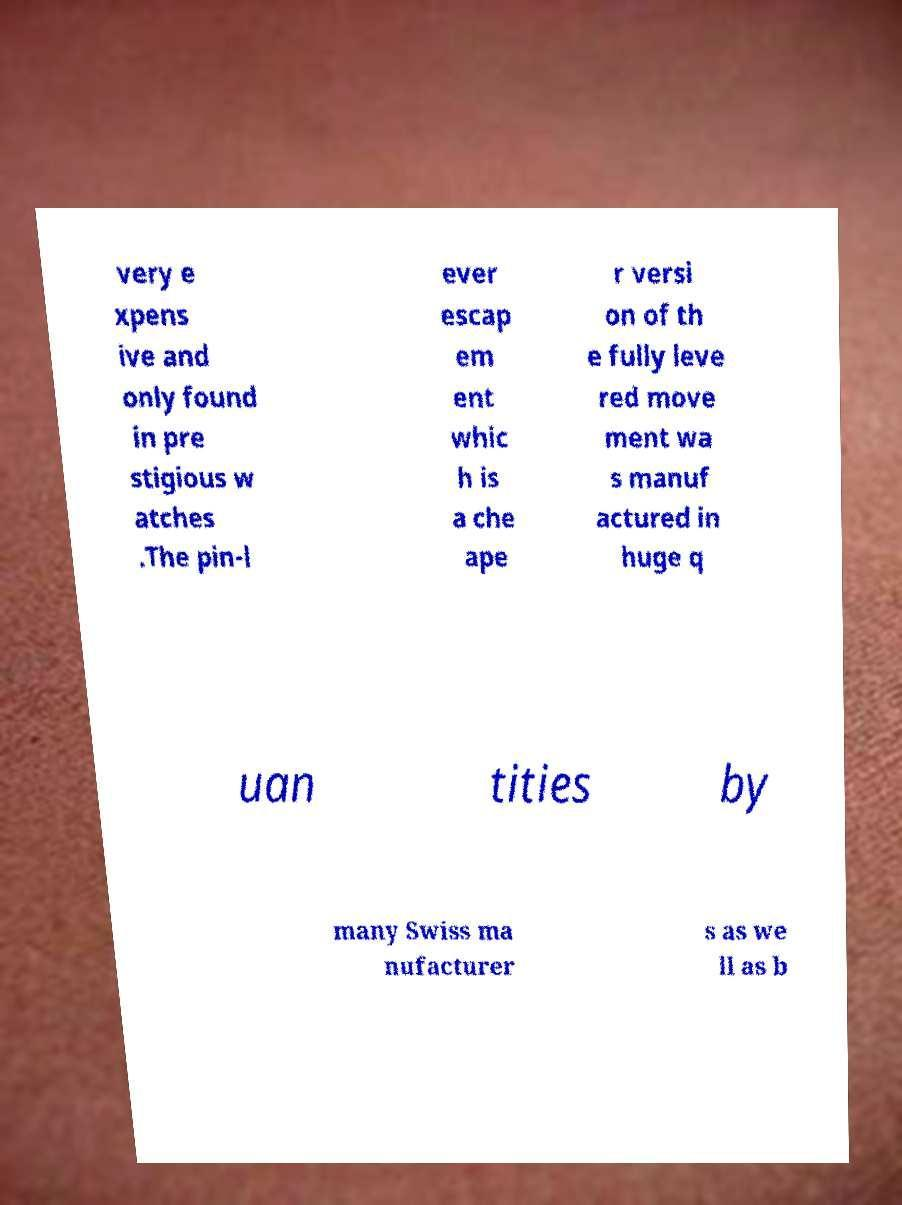Can you accurately transcribe the text from the provided image for me? very e xpens ive and only found in pre stigious w atches .The pin-l ever escap em ent whic h is a che ape r versi on of th e fully leve red move ment wa s manuf actured in huge q uan tities by many Swiss ma nufacturer s as we ll as b 